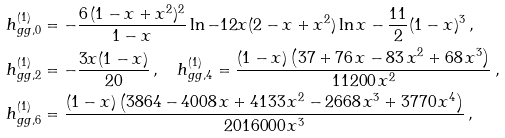<formula> <loc_0><loc_0><loc_500><loc_500>h ^ { ( 1 ) } _ { g g , 0 } & = - \frac { 6 \, ( 1 - x + x ^ { 2 } ) ^ { 2 } } { 1 - x } \ln - 1 2 x ( 2 - x + x ^ { 2 } ) \ln x - \frac { 1 1 } { 2 } { ( 1 - x ) ^ { 3 } } \, , \\ h ^ { ( 1 ) } _ { g g , 2 } & = - \frac { 3 x ( 1 - x ) } { 2 0 } \, , \quad h ^ { ( 1 ) } _ { g g , 4 } = \frac { ( 1 - x ) \left ( 3 7 + 7 6 \, x - 8 3 \, x ^ { 2 } + 6 8 \, x ^ { 3 } \right ) } { 1 1 2 0 0 \, x ^ { 2 } } \, , \\ h ^ { ( 1 ) } _ { g g , 6 } & = \frac { ( 1 - x ) \left ( 3 8 6 4 - 4 0 0 8 \, x + 4 1 3 3 \, x ^ { 2 } - 2 6 6 8 \, x ^ { 3 } + 3 7 7 0 \, x ^ { 4 } \right ) } { 2 0 1 6 0 0 0 \, x ^ { 3 } } \, ,</formula> 